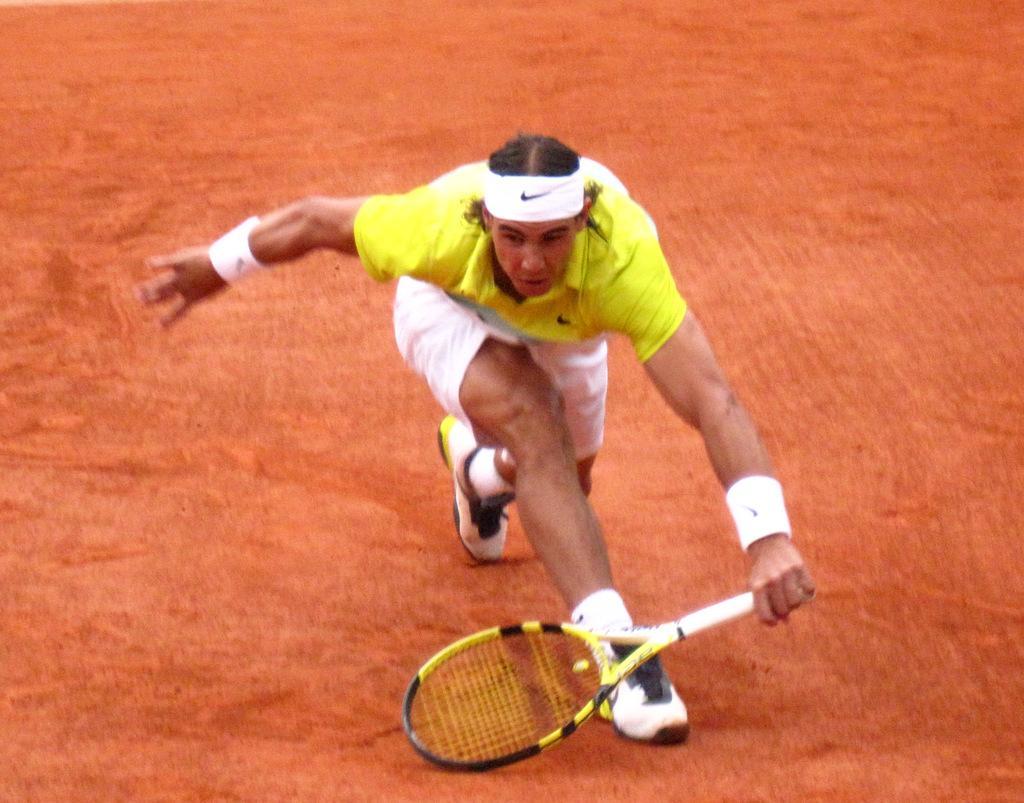Can you describe this image briefly? In this image in the center there is a person holding a bat and is in the action of playing. 